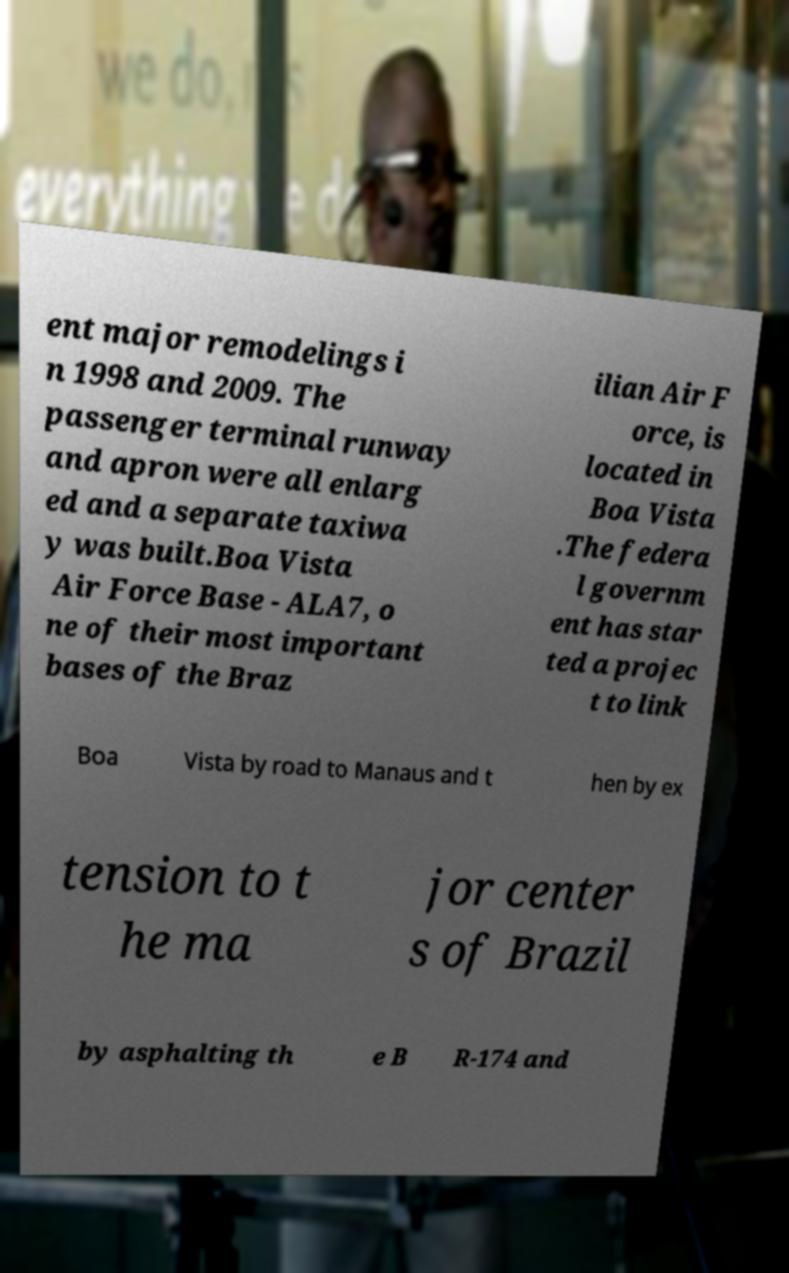There's text embedded in this image that I need extracted. Can you transcribe it verbatim? ent major remodelings i n 1998 and 2009. The passenger terminal runway and apron were all enlarg ed and a separate taxiwa y was built.Boa Vista Air Force Base - ALA7, o ne of their most important bases of the Braz ilian Air F orce, is located in Boa Vista .The federa l governm ent has star ted a projec t to link Boa Vista by road to Manaus and t hen by ex tension to t he ma jor center s of Brazil by asphalting th e B R-174 and 